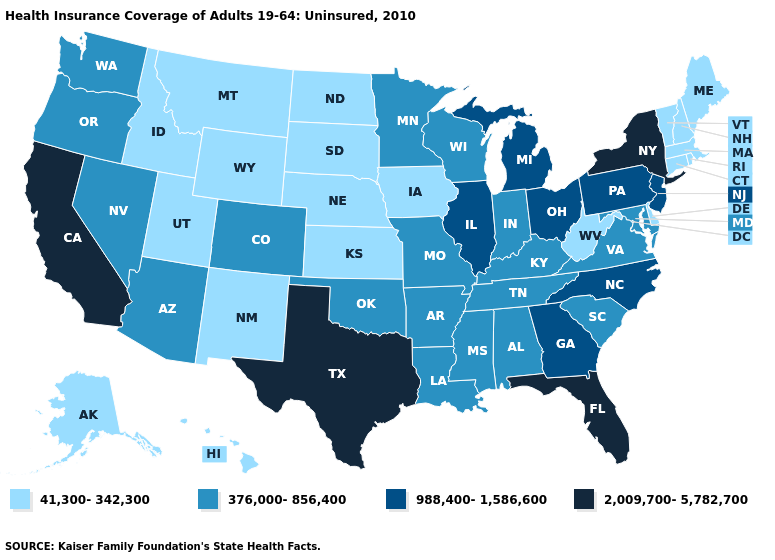Does Washington have the highest value in the West?
Short answer required. No. Which states have the highest value in the USA?
Answer briefly. California, Florida, New York, Texas. Name the states that have a value in the range 376,000-856,400?
Write a very short answer. Alabama, Arizona, Arkansas, Colorado, Indiana, Kentucky, Louisiana, Maryland, Minnesota, Mississippi, Missouri, Nevada, Oklahoma, Oregon, South Carolina, Tennessee, Virginia, Washington, Wisconsin. Name the states that have a value in the range 41,300-342,300?
Answer briefly. Alaska, Connecticut, Delaware, Hawaii, Idaho, Iowa, Kansas, Maine, Massachusetts, Montana, Nebraska, New Hampshire, New Mexico, North Dakota, Rhode Island, South Dakota, Utah, Vermont, West Virginia, Wyoming. What is the value of Kansas?
Keep it brief. 41,300-342,300. Which states have the highest value in the USA?
Short answer required. California, Florida, New York, Texas. What is the value of Arizona?
Short answer required. 376,000-856,400. Is the legend a continuous bar?
Concise answer only. No. What is the lowest value in the West?
Concise answer only. 41,300-342,300. Does the first symbol in the legend represent the smallest category?
Short answer required. Yes. Does the first symbol in the legend represent the smallest category?
Write a very short answer. Yes. Is the legend a continuous bar?
Short answer required. No. What is the lowest value in the Northeast?
Write a very short answer. 41,300-342,300. Does Florida have the lowest value in the South?
Be succinct. No. What is the highest value in the USA?
Short answer required. 2,009,700-5,782,700. 